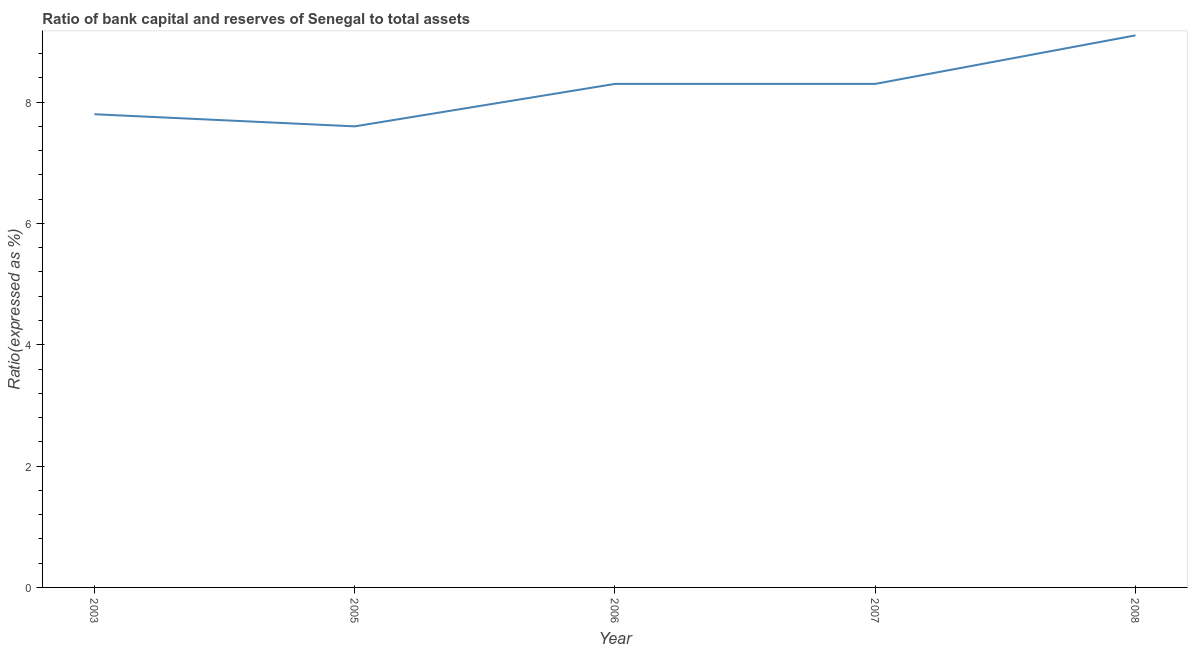What is the bank capital to assets ratio in 2008?
Provide a short and direct response. 9.1. Across all years, what is the maximum bank capital to assets ratio?
Ensure brevity in your answer.  9.1. Across all years, what is the minimum bank capital to assets ratio?
Give a very brief answer. 7.6. In which year was the bank capital to assets ratio maximum?
Provide a succinct answer. 2008. What is the sum of the bank capital to assets ratio?
Make the answer very short. 41.1. What is the difference between the bank capital to assets ratio in 2007 and 2008?
Provide a succinct answer. -0.8. What is the average bank capital to assets ratio per year?
Give a very brief answer. 8.22. What is the median bank capital to assets ratio?
Ensure brevity in your answer.  8.3. In how many years, is the bank capital to assets ratio greater than 6.4 %?
Offer a terse response. 5. Do a majority of the years between 2007 and 2008 (inclusive) have bank capital to assets ratio greater than 2.4 %?
Give a very brief answer. Yes. What is the ratio of the bank capital to assets ratio in 2003 to that in 2005?
Ensure brevity in your answer.  1.03. Is the bank capital to assets ratio in 2005 less than that in 2006?
Your answer should be very brief. Yes. Is the difference between the bank capital to assets ratio in 2003 and 2006 greater than the difference between any two years?
Your answer should be compact. No. What is the difference between the highest and the second highest bank capital to assets ratio?
Offer a terse response. 0.8. What is the difference between the highest and the lowest bank capital to assets ratio?
Give a very brief answer. 1.5. In how many years, is the bank capital to assets ratio greater than the average bank capital to assets ratio taken over all years?
Ensure brevity in your answer.  3. Does the bank capital to assets ratio monotonically increase over the years?
Provide a succinct answer. No. What is the difference between two consecutive major ticks on the Y-axis?
Provide a short and direct response. 2. What is the title of the graph?
Provide a short and direct response. Ratio of bank capital and reserves of Senegal to total assets. What is the label or title of the X-axis?
Keep it short and to the point. Year. What is the label or title of the Y-axis?
Offer a terse response. Ratio(expressed as %). What is the Ratio(expressed as %) in 2006?
Give a very brief answer. 8.3. What is the difference between the Ratio(expressed as %) in 2003 and 2008?
Your answer should be very brief. -1.3. What is the ratio of the Ratio(expressed as %) in 2003 to that in 2007?
Your answer should be very brief. 0.94. What is the ratio of the Ratio(expressed as %) in 2003 to that in 2008?
Provide a succinct answer. 0.86. What is the ratio of the Ratio(expressed as %) in 2005 to that in 2006?
Your answer should be very brief. 0.92. What is the ratio of the Ratio(expressed as %) in 2005 to that in 2007?
Provide a succinct answer. 0.92. What is the ratio of the Ratio(expressed as %) in 2005 to that in 2008?
Provide a short and direct response. 0.83. What is the ratio of the Ratio(expressed as %) in 2006 to that in 2008?
Your response must be concise. 0.91. What is the ratio of the Ratio(expressed as %) in 2007 to that in 2008?
Provide a short and direct response. 0.91. 